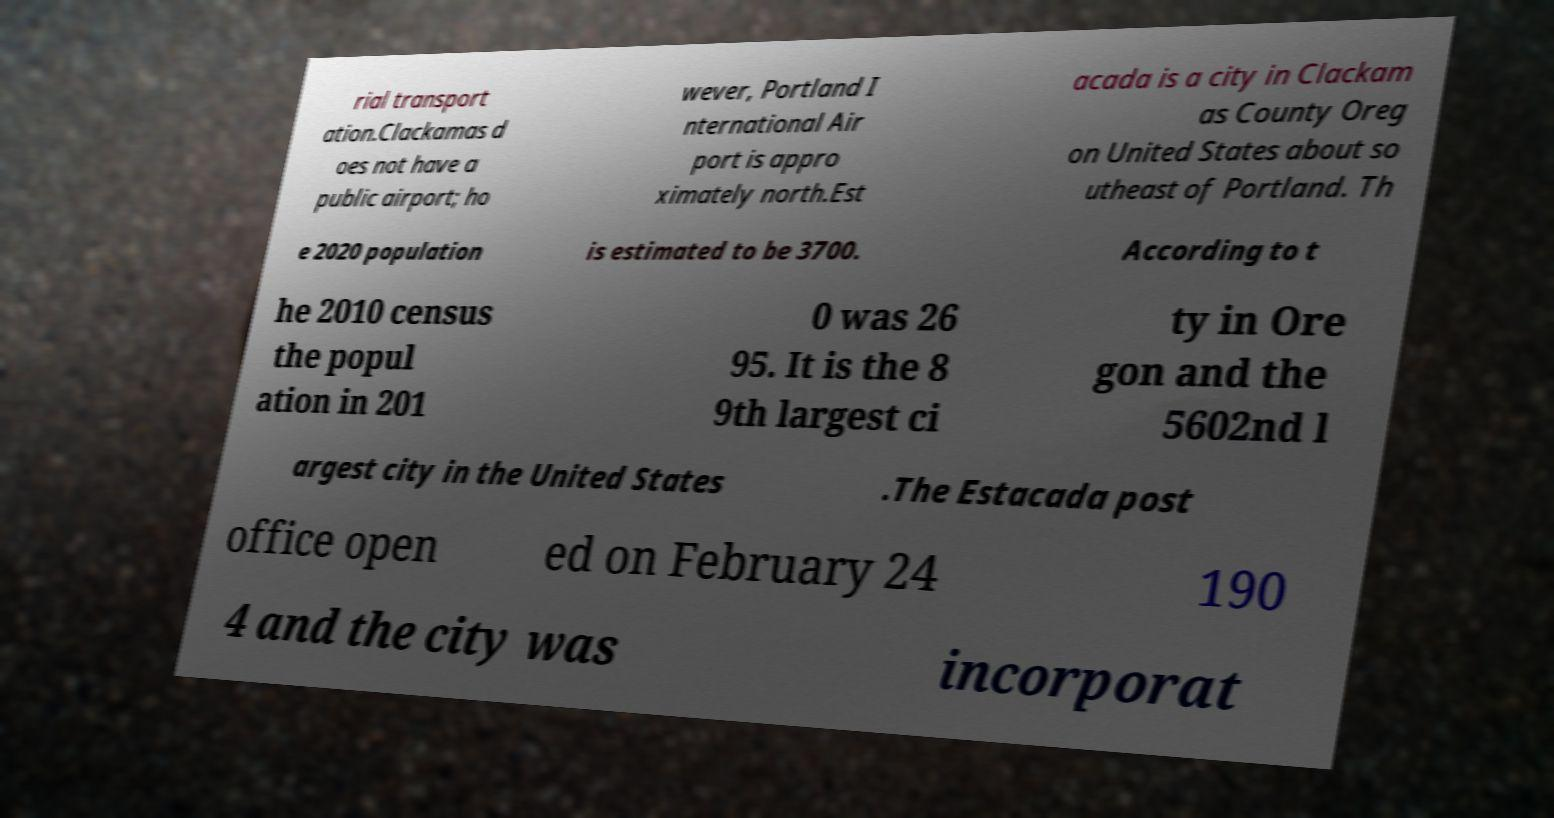What messages or text are displayed in this image? I need them in a readable, typed format. rial transport ation.Clackamas d oes not have a public airport; ho wever, Portland I nternational Air port is appro ximately north.Est acada is a city in Clackam as County Oreg on United States about so utheast of Portland. Th e 2020 population is estimated to be 3700. According to t he 2010 census the popul ation in 201 0 was 26 95. It is the 8 9th largest ci ty in Ore gon and the 5602nd l argest city in the United States .The Estacada post office open ed on February 24 190 4 and the city was incorporat 